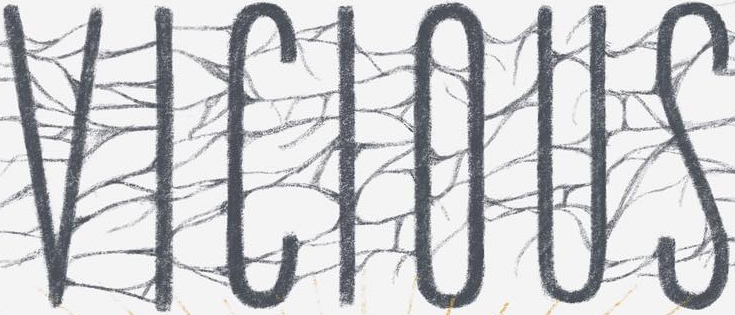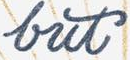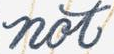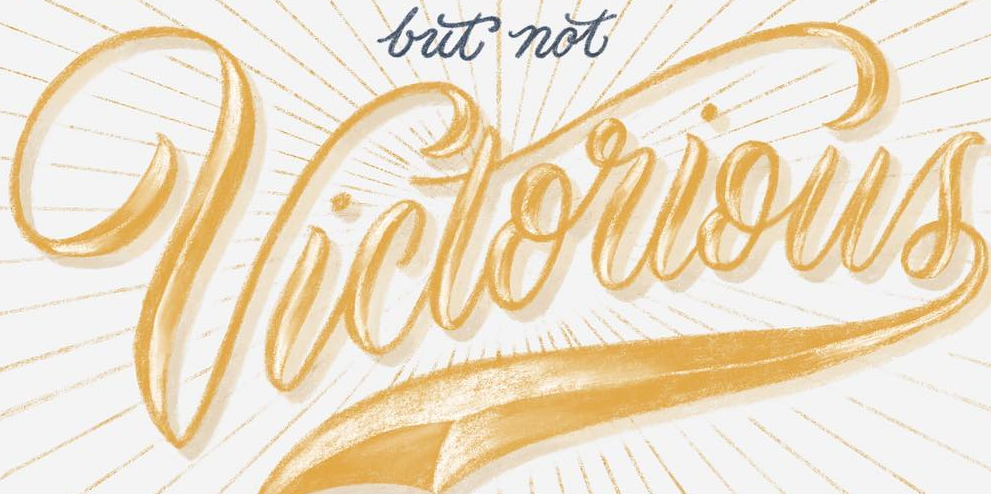Transcribe the words shown in these images in order, separated by a semicolon. VICIOUS; but; not; Victorious 